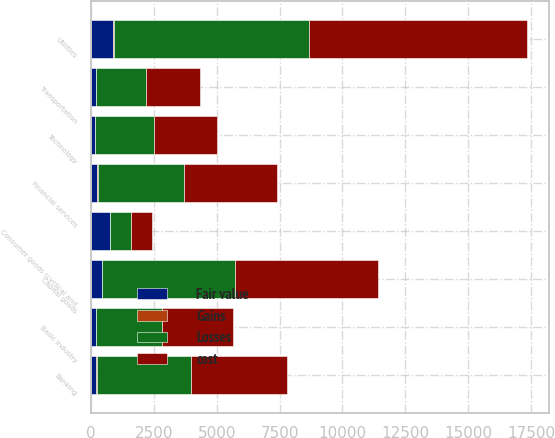<chart> <loc_0><loc_0><loc_500><loc_500><stacked_bar_chart><ecel><fcel>Banking<fcel>Utilities<fcel>Capital goods<fcel>Financial services<fcel>Consumer goods (cyclical and<fcel>Transportation<fcel>Technology<fcel>Basic industry<nl><fcel>Losses<fcel>3707<fcel>7792<fcel>5281<fcel>3436<fcel>818.5<fcel>1960<fcel>2355<fcel>2626<nl><fcel>Fair value<fcel>195<fcel>879<fcel>424<fcel>257<fcel>758<fcel>203<fcel>147<fcel>191<nl><fcel>Gains<fcel>55<fcel>17<fcel>15<fcel>10<fcel>11<fcel>8<fcel>4<fcel>3<nl><fcel>cost<fcel>3847<fcel>8654<fcel>5690<fcel>3683<fcel>818.5<fcel>2155<fcel>2498<fcel>2814<nl></chart> 